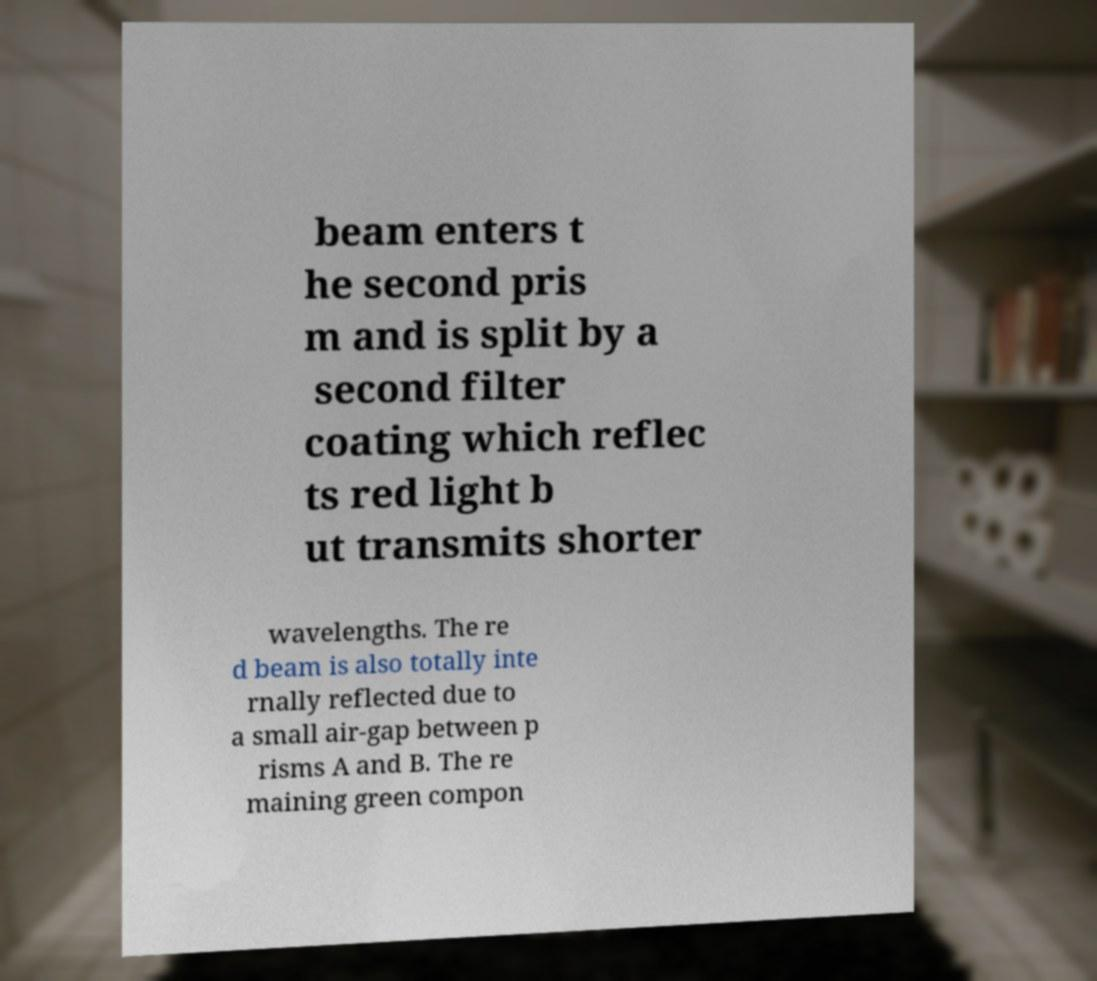Can you accurately transcribe the text from the provided image for me? beam enters t he second pris m and is split by a second filter coating which reflec ts red light b ut transmits shorter wavelengths. The re d beam is also totally inte rnally reflected due to a small air-gap between p risms A and B. The re maining green compon 